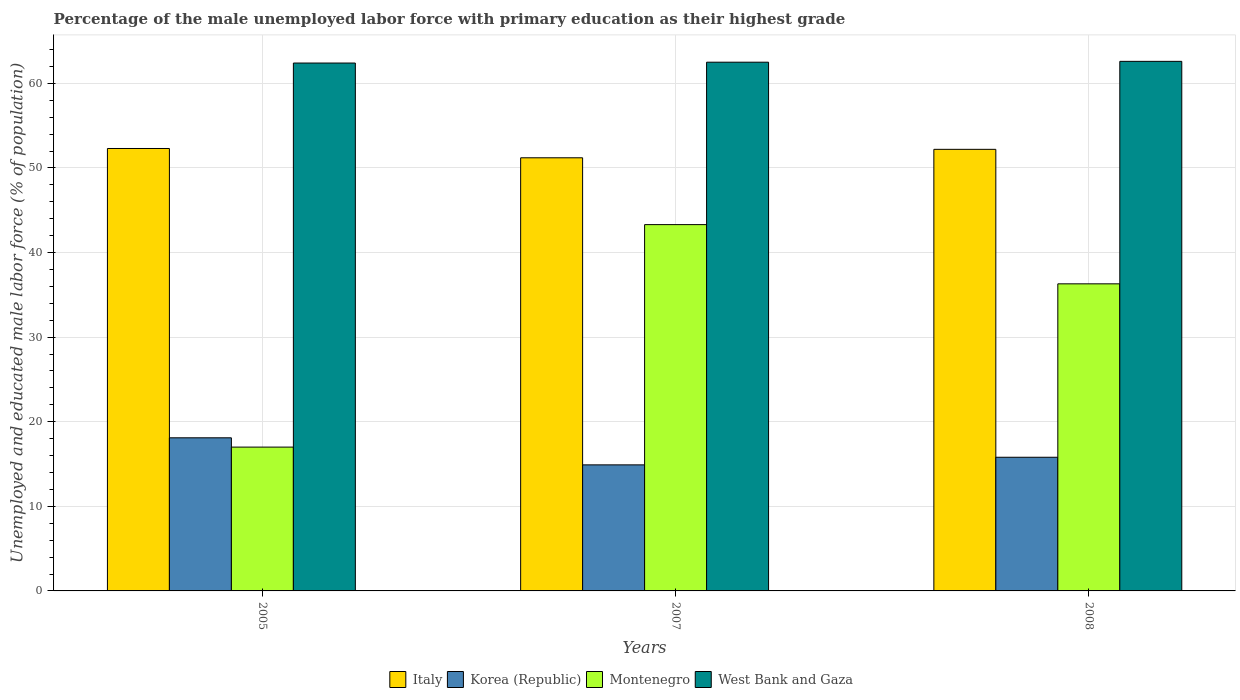How many groups of bars are there?
Your answer should be compact. 3. Are the number of bars per tick equal to the number of legend labels?
Ensure brevity in your answer.  Yes. How many bars are there on the 2nd tick from the left?
Your answer should be compact. 4. What is the label of the 1st group of bars from the left?
Make the answer very short. 2005. What is the percentage of the unemployed male labor force with primary education in Korea (Republic) in 2005?
Your answer should be compact. 18.1. Across all years, what is the maximum percentage of the unemployed male labor force with primary education in West Bank and Gaza?
Provide a short and direct response. 62.6. Across all years, what is the minimum percentage of the unemployed male labor force with primary education in Italy?
Your response must be concise. 51.2. In which year was the percentage of the unemployed male labor force with primary education in Korea (Republic) maximum?
Keep it short and to the point. 2005. In which year was the percentage of the unemployed male labor force with primary education in Montenegro minimum?
Provide a succinct answer. 2005. What is the total percentage of the unemployed male labor force with primary education in Italy in the graph?
Make the answer very short. 155.7. What is the difference between the percentage of the unemployed male labor force with primary education in Italy in 2005 and that in 2008?
Keep it short and to the point. 0.1. What is the difference between the percentage of the unemployed male labor force with primary education in Montenegro in 2008 and the percentage of the unemployed male labor force with primary education in West Bank and Gaza in 2007?
Offer a terse response. -26.2. What is the average percentage of the unemployed male labor force with primary education in Korea (Republic) per year?
Your response must be concise. 16.27. In the year 2007, what is the difference between the percentage of the unemployed male labor force with primary education in Korea (Republic) and percentage of the unemployed male labor force with primary education in Italy?
Your response must be concise. -36.3. What is the ratio of the percentage of the unemployed male labor force with primary education in Italy in 2005 to that in 2008?
Your answer should be compact. 1. What is the difference between the highest and the lowest percentage of the unemployed male labor force with primary education in Korea (Republic)?
Offer a very short reply. 3.2. In how many years, is the percentage of the unemployed male labor force with primary education in Montenegro greater than the average percentage of the unemployed male labor force with primary education in Montenegro taken over all years?
Give a very brief answer. 2. Is the sum of the percentage of the unemployed male labor force with primary education in Montenegro in 2005 and 2007 greater than the maximum percentage of the unemployed male labor force with primary education in Korea (Republic) across all years?
Keep it short and to the point. Yes. What does the 1st bar from the left in 2007 represents?
Your answer should be very brief. Italy. Is it the case that in every year, the sum of the percentage of the unemployed male labor force with primary education in Montenegro and percentage of the unemployed male labor force with primary education in Korea (Republic) is greater than the percentage of the unemployed male labor force with primary education in West Bank and Gaza?
Offer a very short reply. No. Are all the bars in the graph horizontal?
Ensure brevity in your answer.  No. How many years are there in the graph?
Provide a short and direct response. 3. What is the difference between two consecutive major ticks on the Y-axis?
Make the answer very short. 10. Are the values on the major ticks of Y-axis written in scientific E-notation?
Make the answer very short. No. Where does the legend appear in the graph?
Provide a short and direct response. Bottom center. How are the legend labels stacked?
Ensure brevity in your answer.  Horizontal. What is the title of the graph?
Your answer should be very brief. Percentage of the male unemployed labor force with primary education as their highest grade. Does "Canada" appear as one of the legend labels in the graph?
Ensure brevity in your answer.  No. What is the label or title of the X-axis?
Your answer should be very brief. Years. What is the label or title of the Y-axis?
Offer a terse response. Unemployed and educated male labor force (% of population). What is the Unemployed and educated male labor force (% of population) of Italy in 2005?
Your response must be concise. 52.3. What is the Unemployed and educated male labor force (% of population) of Korea (Republic) in 2005?
Provide a succinct answer. 18.1. What is the Unemployed and educated male labor force (% of population) in Montenegro in 2005?
Offer a very short reply. 17. What is the Unemployed and educated male labor force (% of population) of West Bank and Gaza in 2005?
Offer a very short reply. 62.4. What is the Unemployed and educated male labor force (% of population) in Italy in 2007?
Offer a terse response. 51.2. What is the Unemployed and educated male labor force (% of population) of Korea (Republic) in 2007?
Make the answer very short. 14.9. What is the Unemployed and educated male labor force (% of population) in Montenegro in 2007?
Keep it short and to the point. 43.3. What is the Unemployed and educated male labor force (% of population) in West Bank and Gaza in 2007?
Your answer should be compact. 62.5. What is the Unemployed and educated male labor force (% of population) in Italy in 2008?
Provide a succinct answer. 52.2. What is the Unemployed and educated male labor force (% of population) in Korea (Republic) in 2008?
Ensure brevity in your answer.  15.8. What is the Unemployed and educated male labor force (% of population) in Montenegro in 2008?
Offer a terse response. 36.3. What is the Unemployed and educated male labor force (% of population) in West Bank and Gaza in 2008?
Your response must be concise. 62.6. Across all years, what is the maximum Unemployed and educated male labor force (% of population) of Italy?
Make the answer very short. 52.3. Across all years, what is the maximum Unemployed and educated male labor force (% of population) of Korea (Republic)?
Keep it short and to the point. 18.1. Across all years, what is the maximum Unemployed and educated male labor force (% of population) in Montenegro?
Offer a terse response. 43.3. Across all years, what is the maximum Unemployed and educated male labor force (% of population) of West Bank and Gaza?
Provide a succinct answer. 62.6. Across all years, what is the minimum Unemployed and educated male labor force (% of population) of Italy?
Your response must be concise. 51.2. Across all years, what is the minimum Unemployed and educated male labor force (% of population) in Korea (Republic)?
Keep it short and to the point. 14.9. Across all years, what is the minimum Unemployed and educated male labor force (% of population) of West Bank and Gaza?
Ensure brevity in your answer.  62.4. What is the total Unemployed and educated male labor force (% of population) of Italy in the graph?
Provide a succinct answer. 155.7. What is the total Unemployed and educated male labor force (% of population) of Korea (Republic) in the graph?
Ensure brevity in your answer.  48.8. What is the total Unemployed and educated male labor force (% of population) in Montenegro in the graph?
Make the answer very short. 96.6. What is the total Unemployed and educated male labor force (% of population) in West Bank and Gaza in the graph?
Your response must be concise. 187.5. What is the difference between the Unemployed and educated male labor force (% of population) of Montenegro in 2005 and that in 2007?
Give a very brief answer. -26.3. What is the difference between the Unemployed and educated male labor force (% of population) in West Bank and Gaza in 2005 and that in 2007?
Keep it short and to the point. -0.1. What is the difference between the Unemployed and educated male labor force (% of population) in Montenegro in 2005 and that in 2008?
Make the answer very short. -19.3. What is the difference between the Unemployed and educated male labor force (% of population) in Italy in 2007 and that in 2008?
Keep it short and to the point. -1. What is the difference between the Unemployed and educated male labor force (% of population) of Italy in 2005 and the Unemployed and educated male labor force (% of population) of Korea (Republic) in 2007?
Give a very brief answer. 37.4. What is the difference between the Unemployed and educated male labor force (% of population) in Italy in 2005 and the Unemployed and educated male labor force (% of population) in West Bank and Gaza in 2007?
Your answer should be very brief. -10.2. What is the difference between the Unemployed and educated male labor force (% of population) of Korea (Republic) in 2005 and the Unemployed and educated male labor force (% of population) of Montenegro in 2007?
Your response must be concise. -25.2. What is the difference between the Unemployed and educated male labor force (% of population) of Korea (Republic) in 2005 and the Unemployed and educated male labor force (% of population) of West Bank and Gaza in 2007?
Your answer should be compact. -44.4. What is the difference between the Unemployed and educated male labor force (% of population) in Montenegro in 2005 and the Unemployed and educated male labor force (% of population) in West Bank and Gaza in 2007?
Provide a short and direct response. -45.5. What is the difference between the Unemployed and educated male labor force (% of population) of Italy in 2005 and the Unemployed and educated male labor force (% of population) of Korea (Republic) in 2008?
Provide a succinct answer. 36.5. What is the difference between the Unemployed and educated male labor force (% of population) in Italy in 2005 and the Unemployed and educated male labor force (% of population) in Montenegro in 2008?
Make the answer very short. 16. What is the difference between the Unemployed and educated male labor force (% of population) of Korea (Republic) in 2005 and the Unemployed and educated male labor force (% of population) of Montenegro in 2008?
Keep it short and to the point. -18.2. What is the difference between the Unemployed and educated male labor force (% of population) in Korea (Republic) in 2005 and the Unemployed and educated male labor force (% of population) in West Bank and Gaza in 2008?
Your answer should be very brief. -44.5. What is the difference between the Unemployed and educated male labor force (% of population) in Montenegro in 2005 and the Unemployed and educated male labor force (% of population) in West Bank and Gaza in 2008?
Provide a short and direct response. -45.6. What is the difference between the Unemployed and educated male labor force (% of population) of Italy in 2007 and the Unemployed and educated male labor force (% of population) of Korea (Republic) in 2008?
Give a very brief answer. 35.4. What is the difference between the Unemployed and educated male labor force (% of population) of Italy in 2007 and the Unemployed and educated male labor force (% of population) of Montenegro in 2008?
Your answer should be very brief. 14.9. What is the difference between the Unemployed and educated male labor force (% of population) of Italy in 2007 and the Unemployed and educated male labor force (% of population) of West Bank and Gaza in 2008?
Your answer should be compact. -11.4. What is the difference between the Unemployed and educated male labor force (% of population) of Korea (Republic) in 2007 and the Unemployed and educated male labor force (% of population) of Montenegro in 2008?
Offer a very short reply. -21.4. What is the difference between the Unemployed and educated male labor force (% of population) of Korea (Republic) in 2007 and the Unemployed and educated male labor force (% of population) of West Bank and Gaza in 2008?
Offer a very short reply. -47.7. What is the difference between the Unemployed and educated male labor force (% of population) in Montenegro in 2007 and the Unemployed and educated male labor force (% of population) in West Bank and Gaza in 2008?
Provide a short and direct response. -19.3. What is the average Unemployed and educated male labor force (% of population) of Italy per year?
Your answer should be compact. 51.9. What is the average Unemployed and educated male labor force (% of population) of Korea (Republic) per year?
Offer a terse response. 16.27. What is the average Unemployed and educated male labor force (% of population) of Montenegro per year?
Your answer should be very brief. 32.2. What is the average Unemployed and educated male labor force (% of population) in West Bank and Gaza per year?
Provide a short and direct response. 62.5. In the year 2005, what is the difference between the Unemployed and educated male labor force (% of population) of Italy and Unemployed and educated male labor force (% of population) of Korea (Republic)?
Your response must be concise. 34.2. In the year 2005, what is the difference between the Unemployed and educated male labor force (% of population) of Italy and Unemployed and educated male labor force (% of population) of Montenegro?
Provide a short and direct response. 35.3. In the year 2005, what is the difference between the Unemployed and educated male labor force (% of population) in Italy and Unemployed and educated male labor force (% of population) in West Bank and Gaza?
Give a very brief answer. -10.1. In the year 2005, what is the difference between the Unemployed and educated male labor force (% of population) in Korea (Republic) and Unemployed and educated male labor force (% of population) in West Bank and Gaza?
Offer a very short reply. -44.3. In the year 2005, what is the difference between the Unemployed and educated male labor force (% of population) in Montenegro and Unemployed and educated male labor force (% of population) in West Bank and Gaza?
Offer a terse response. -45.4. In the year 2007, what is the difference between the Unemployed and educated male labor force (% of population) in Italy and Unemployed and educated male labor force (% of population) in Korea (Republic)?
Give a very brief answer. 36.3. In the year 2007, what is the difference between the Unemployed and educated male labor force (% of population) of Italy and Unemployed and educated male labor force (% of population) of Montenegro?
Ensure brevity in your answer.  7.9. In the year 2007, what is the difference between the Unemployed and educated male labor force (% of population) in Korea (Republic) and Unemployed and educated male labor force (% of population) in Montenegro?
Your answer should be very brief. -28.4. In the year 2007, what is the difference between the Unemployed and educated male labor force (% of population) in Korea (Republic) and Unemployed and educated male labor force (% of population) in West Bank and Gaza?
Offer a very short reply. -47.6. In the year 2007, what is the difference between the Unemployed and educated male labor force (% of population) in Montenegro and Unemployed and educated male labor force (% of population) in West Bank and Gaza?
Your answer should be very brief. -19.2. In the year 2008, what is the difference between the Unemployed and educated male labor force (% of population) in Italy and Unemployed and educated male labor force (% of population) in Korea (Republic)?
Your answer should be compact. 36.4. In the year 2008, what is the difference between the Unemployed and educated male labor force (% of population) of Korea (Republic) and Unemployed and educated male labor force (% of population) of Montenegro?
Ensure brevity in your answer.  -20.5. In the year 2008, what is the difference between the Unemployed and educated male labor force (% of population) in Korea (Republic) and Unemployed and educated male labor force (% of population) in West Bank and Gaza?
Offer a very short reply. -46.8. In the year 2008, what is the difference between the Unemployed and educated male labor force (% of population) of Montenegro and Unemployed and educated male labor force (% of population) of West Bank and Gaza?
Provide a succinct answer. -26.3. What is the ratio of the Unemployed and educated male labor force (% of population) of Italy in 2005 to that in 2007?
Provide a succinct answer. 1.02. What is the ratio of the Unemployed and educated male labor force (% of population) in Korea (Republic) in 2005 to that in 2007?
Offer a very short reply. 1.21. What is the ratio of the Unemployed and educated male labor force (% of population) in Montenegro in 2005 to that in 2007?
Your answer should be very brief. 0.39. What is the ratio of the Unemployed and educated male labor force (% of population) in Korea (Republic) in 2005 to that in 2008?
Your answer should be very brief. 1.15. What is the ratio of the Unemployed and educated male labor force (% of population) in Montenegro in 2005 to that in 2008?
Provide a short and direct response. 0.47. What is the ratio of the Unemployed and educated male labor force (% of population) of West Bank and Gaza in 2005 to that in 2008?
Offer a terse response. 1. What is the ratio of the Unemployed and educated male labor force (% of population) in Italy in 2007 to that in 2008?
Offer a terse response. 0.98. What is the ratio of the Unemployed and educated male labor force (% of population) in Korea (Republic) in 2007 to that in 2008?
Give a very brief answer. 0.94. What is the ratio of the Unemployed and educated male labor force (% of population) of Montenegro in 2007 to that in 2008?
Offer a very short reply. 1.19. What is the difference between the highest and the second highest Unemployed and educated male labor force (% of population) in Korea (Republic)?
Ensure brevity in your answer.  2.3. What is the difference between the highest and the second highest Unemployed and educated male labor force (% of population) in West Bank and Gaza?
Make the answer very short. 0.1. What is the difference between the highest and the lowest Unemployed and educated male labor force (% of population) in Korea (Republic)?
Provide a succinct answer. 3.2. What is the difference between the highest and the lowest Unemployed and educated male labor force (% of population) of Montenegro?
Provide a short and direct response. 26.3. 